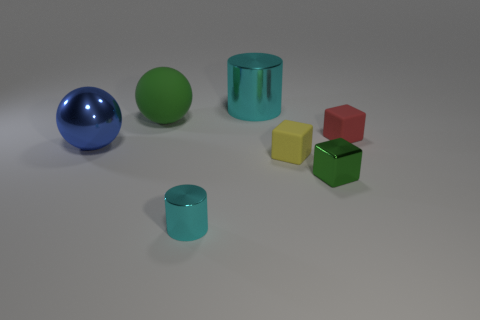Add 2 blue things. How many objects exist? 9 Subtract all cylinders. How many objects are left? 5 Add 6 small red matte things. How many small red matte things are left? 7 Add 3 blocks. How many blocks exist? 6 Subtract 0 gray spheres. How many objects are left? 7 Subtract all tiny matte things. Subtract all small yellow rubber objects. How many objects are left? 4 